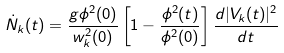<formula> <loc_0><loc_0><loc_500><loc_500>\dot { N } _ { k } ( t ) = \frac { g \phi ^ { 2 } ( 0 ) } { w _ { k } ^ { 2 } ( 0 ) } \left [ 1 - \frac { \phi ^ { 2 } ( t ) } { \phi ^ { 2 } ( 0 ) } \right ] \frac { d | V _ { k } ( t ) | ^ { 2 } } { d t }</formula> 